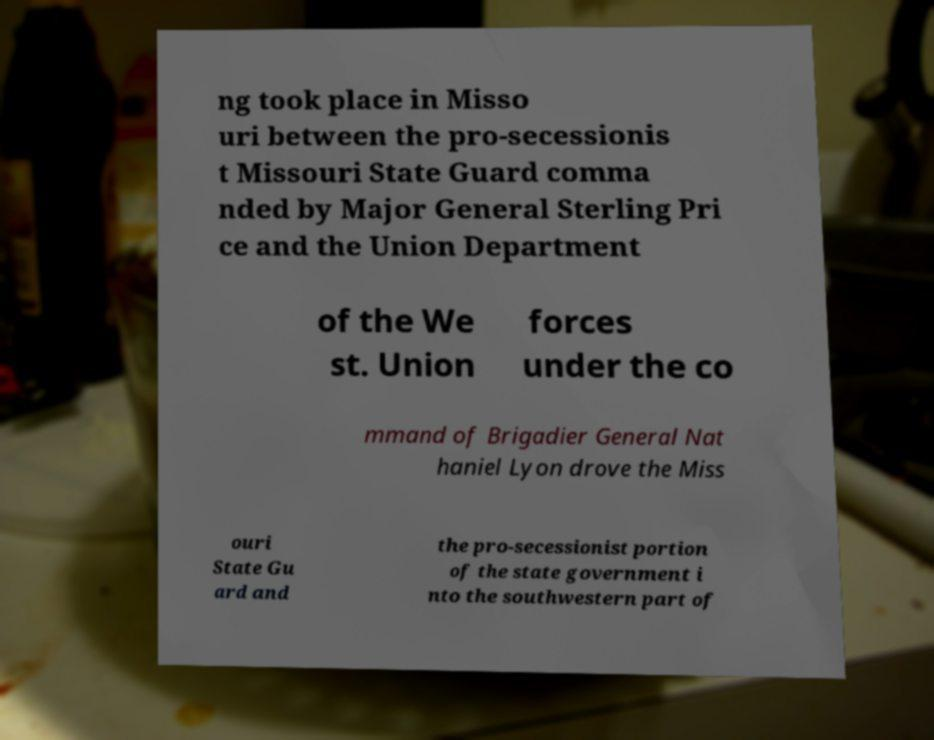What messages or text are displayed in this image? I need them in a readable, typed format. ng took place in Misso uri between the pro-secessionis t Missouri State Guard comma nded by Major General Sterling Pri ce and the Union Department of the We st. Union forces under the co mmand of Brigadier General Nat haniel Lyon drove the Miss ouri State Gu ard and the pro-secessionist portion of the state government i nto the southwestern part of 